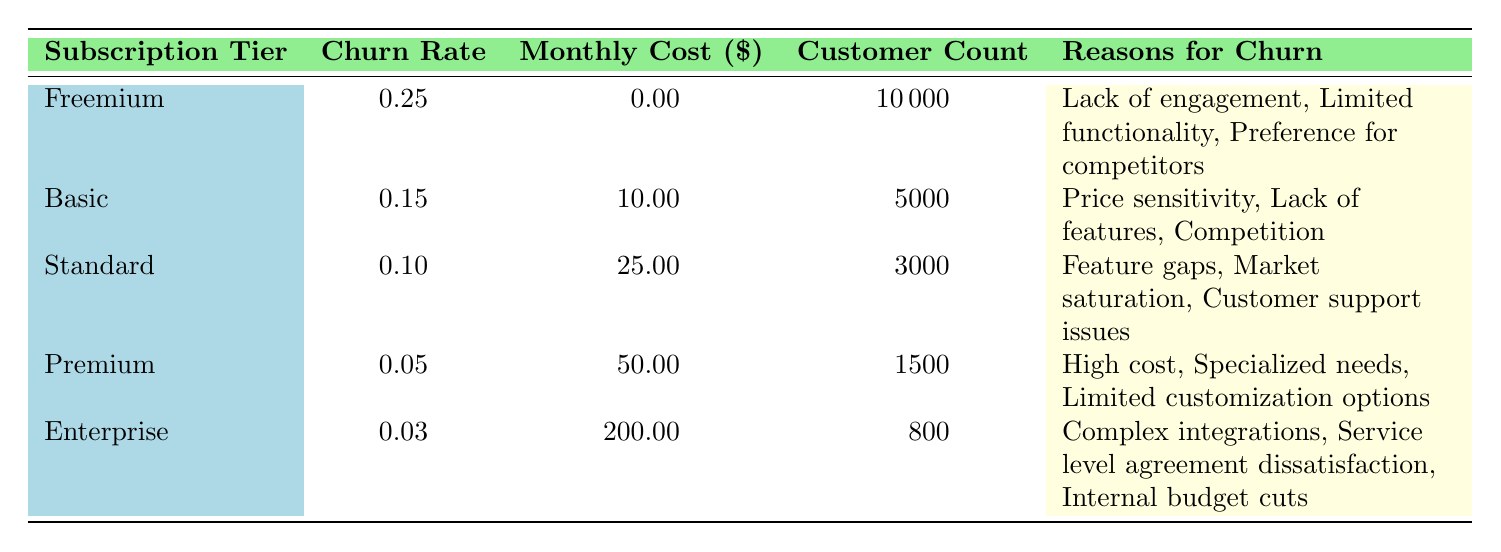What is the churn rate for the Basic subscription tier? The table lists the churn rates for each subscription tier, and the Basic tier shows a churn rate of 0.15.
Answer: 0.15 How many customers are subscribed to the Premium tier? Looking at the table, the Premium subscription tier has a customer count of 1500 listed directly.
Answer: 1500 What is the average churn rate across all subscription tiers? To find the average churn rate, add the churn rates for all tiers: 0.25 + 0.15 + 0.10 + 0.05 + 0.03 = 0.58. Dividing this sum by the number of tiers (5) gives an average of 0.58/5 = 0.116.
Answer: 0.116 Is there a higher churn rate in Freemium than in Enterprise? The churn rate for Freemium is 0.25, while the churn rate for Enterprise is 0.03. Since 0.25 is greater than 0.03, the statement is true.
Answer: Yes Which subscription tier has the highest churn rate and what is it? The Freemium tier has the highest churn rate at 0.25, as shown in the table.
Answer: Freemium, 0.25 What is the difference in customer count between the Basic and Standard tiers? The Basic tier has 5000 customers and the Standard tier has 3000 customers. The difference is 5000 - 3000 = 2000.
Answer: 2000 Does the Premium tier have more customers than the Standard tier? The Premium tier has 1500 customers whereas the Standard tier has 3000 customers. Since 1500 is less than 3000, the statement is false.
Answer: No What are the primary reasons for churn in the Basic tier? The table lists the reasons for churn specific to the Basic tier as Price sensitivity, Lack of features, and Competition.
Answer: Price sensitivity, Lack of features, Competition Which tier has the lowest churn rate and what are its reasons for churn? The Enterprise tier has the lowest churn rate at 0.03, and its reasons for churn are Complex integrations, Service level agreement dissatisfaction, and Internal budget cuts.
Answer: Enterprise, Complex integrations, Service level agreement dissatisfaction, Internal budget cuts 